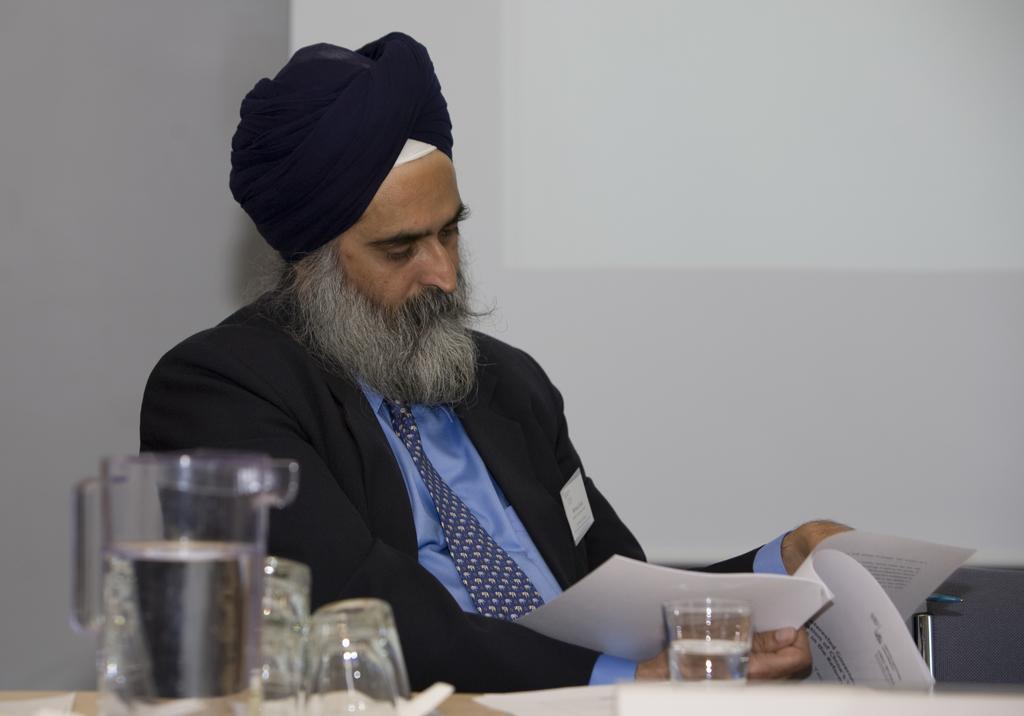Describe this image in one or two sentences. In this image, we can see a person wearing clothes and holding a book with his hand. There are glasses at the bottom of the image. There is a jug in the bottom left of the image. 